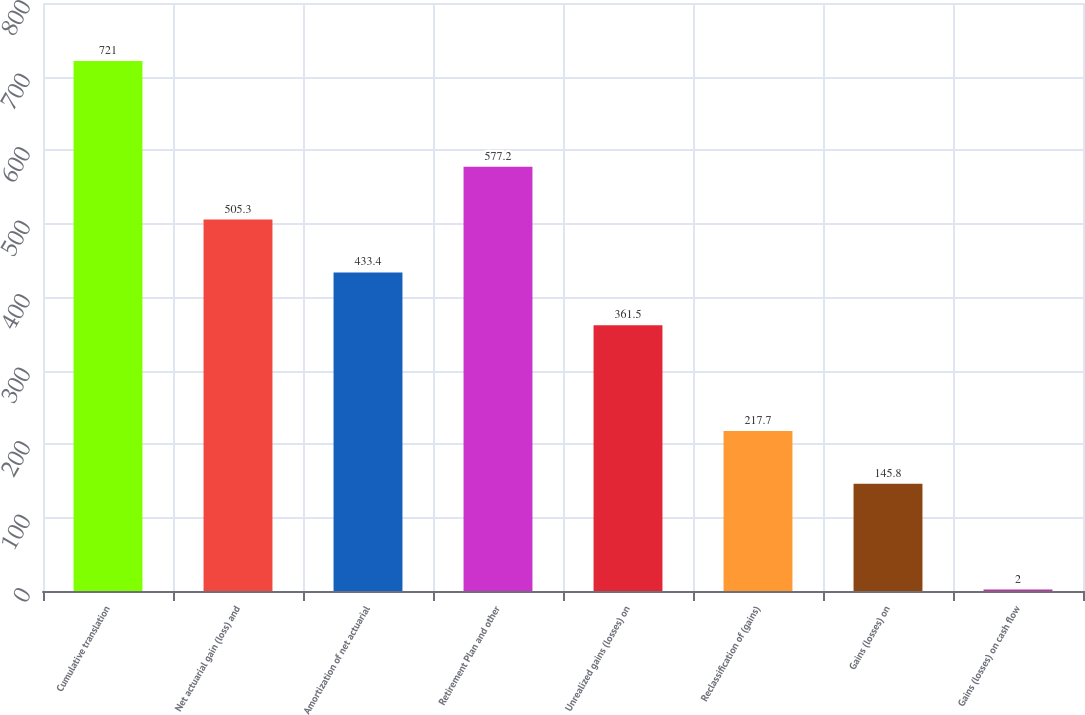Convert chart. <chart><loc_0><loc_0><loc_500><loc_500><bar_chart><fcel>Cumulative translation<fcel>Net actuarial gain (loss) and<fcel>Amortization of net actuarial<fcel>Retirement Plan and other<fcel>Unrealized gains (losses) on<fcel>Reclassification of (gains)<fcel>Gains (losses) on<fcel>Gains (losses) on cash flow<nl><fcel>721<fcel>505.3<fcel>433.4<fcel>577.2<fcel>361.5<fcel>217.7<fcel>145.8<fcel>2<nl></chart> 